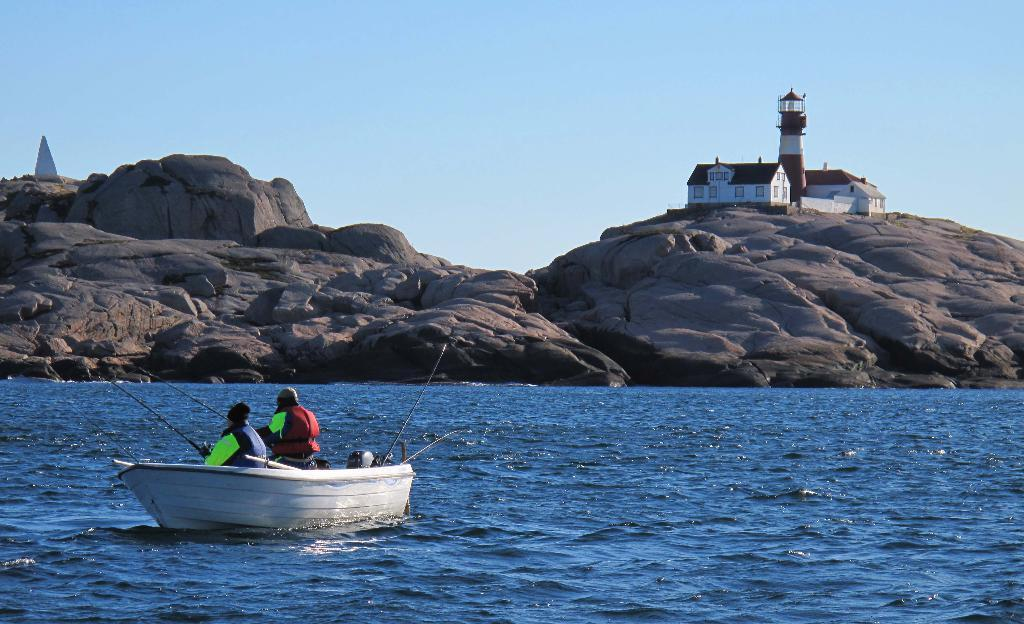What is the main subject in the center of the image? There is a boat in the center of the image. What is the boat doing in the image? The boat is sailing on the water. Are there any people on the boat? Yes, there are persons sitting inside the boat. What can be seen in the background of the image? There are rocks, houses, and a tower in the background of the image. What type of waste is being disposed of in the water near the boat? There is no waste being disposed of in the water near the boat in the image. Can you see a bat flying near the boat in the image? There is no bat visible in the image; it only features a boat sailing on the water with people on board. 